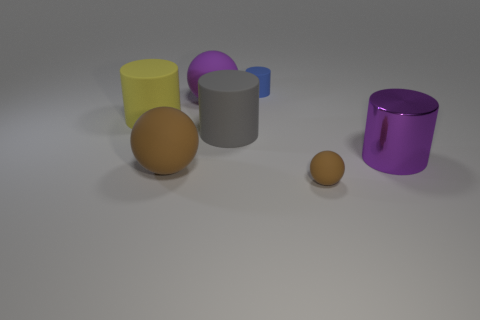Is the number of yellow matte objects less than the number of objects?
Ensure brevity in your answer.  Yes. What number of small cylinders have the same material as the tiny brown object?
Ensure brevity in your answer.  1. What is the color of the other tiny sphere that is made of the same material as the purple sphere?
Offer a terse response. Brown. What is the shape of the small blue object?
Offer a very short reply. Cylinder. What number of metallic cylinders have the same color as the tiny rubber sphere?
Ensure brevity in your answer.  0. There is a purple matte object that is the same size as the yellow thing; what is its shape?
Provide a succinct answer. Sphere. Are there any purple matte balls of the same size as the yellow cylinder?
Your answer should be very brief. Yes. There is a gray cylinder that is the same size as the yellow object; what is its material?
Make the answer very short. Rubber. There is a purple thing in front of the large purple object on the left side of the small brown object; what is its size?
Offer a very short reply. Large. There is a purple object behind the gray thing; is it the same size as the small brown thing?
Offer a very short reply. No. 